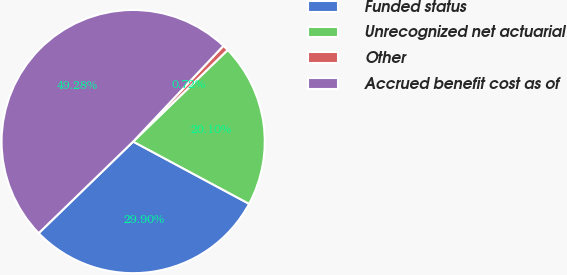Convert chart. <chart><loc_0><loc_0><loc_500><loc_500><pie_chart><fcel>Funded status<fcel>Unrecognized net actuarial<fcel>Other<fcel>Accrued benefit cost as of<nl><fcel>29.9%<fcel>20.1%<fcel>0.72%<fcel>49.28%<nl></chart> 